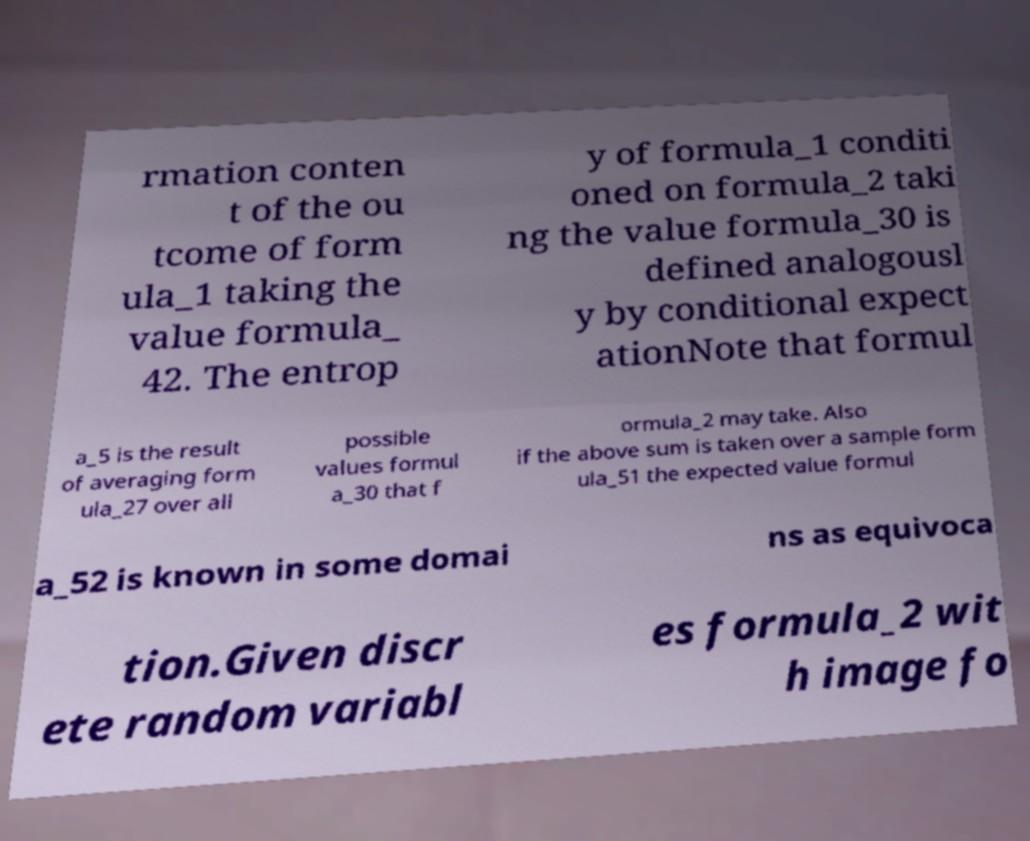Can you read and provide the text displayed in the image?This photo seems to have some interesting text. Can you extract and type it out for me? rmation conten t of the ou tcome of form ula_1 taking the value formula_ 42. The entrop y of formula_1 conditi oned on formula_2 taki ng the value formula_30 is defined analogousl y by conditional expect ationNote that formul a_5 is the result of averaging form ula_27 over all possible values formul a_30 that f ormula_2 may take. Also if the above sum is taken over a sample form ula_51 the expected value formul a_52 is known in some domai ns as equivoca tion.Given discr ete random variabl es formula_2 wit h image fo 